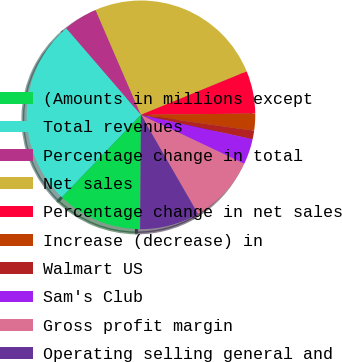Convert chart. <chart><loc_0><loc_0><loc_500><loc_500><pie_chart><fcel>(Amounts in millions except<fcel>Total revenues<fcel>Percentage change in total<fcel>Net sales<fcel>Percentage change in net sales<fcel>Increase (decrease) in<fcel>Walmart US<fcel>Sam's Club<fcel>Gross profit margin<fcel>Operating selling general and<nl><fcel>12.05%<fcel>26.51%<fcel>4.82%<fcel>25.3%<fcel>6.02%<fcel>2.41%<fcel>1.2%<fcel>3.61%<fcel>9.64%<fcel>8.43%<nl></chart> 